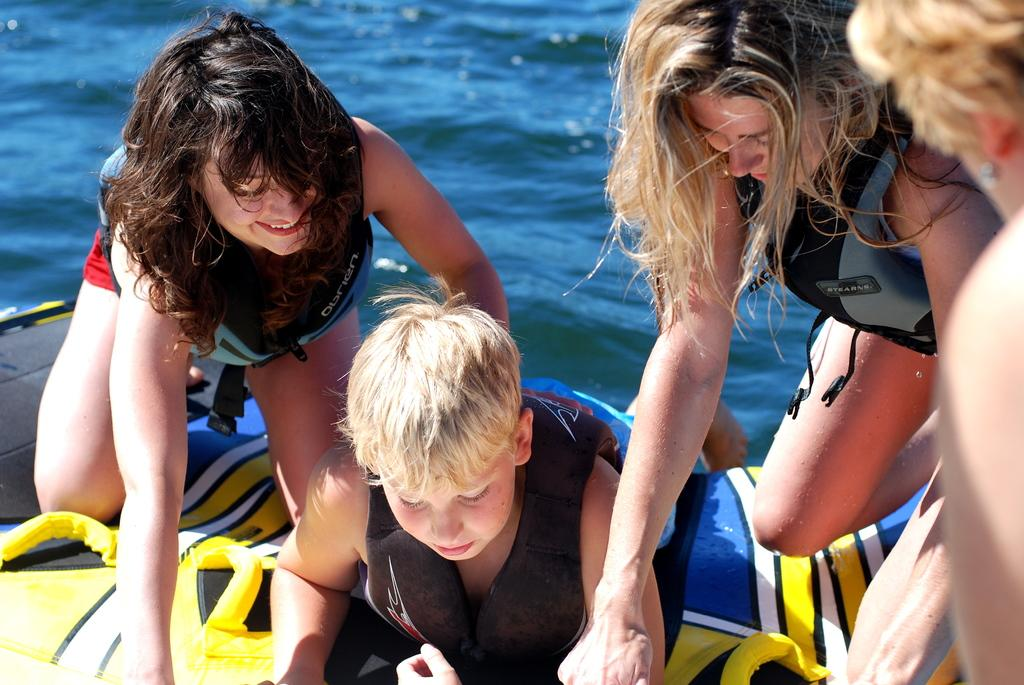How many people are in the image? There are four people in the image. What are the people wearing in the image? The people are wearing life jackets in the image. Where are the people sitting in the image? The people are sitting on a boat in the image. What can be seen in the background of the image? There is water visible in the image. What type of jam is being spread on the mice in the image? There are no mice or jam present in the image; it features four people wearing life jackets and sitting on a boat. 